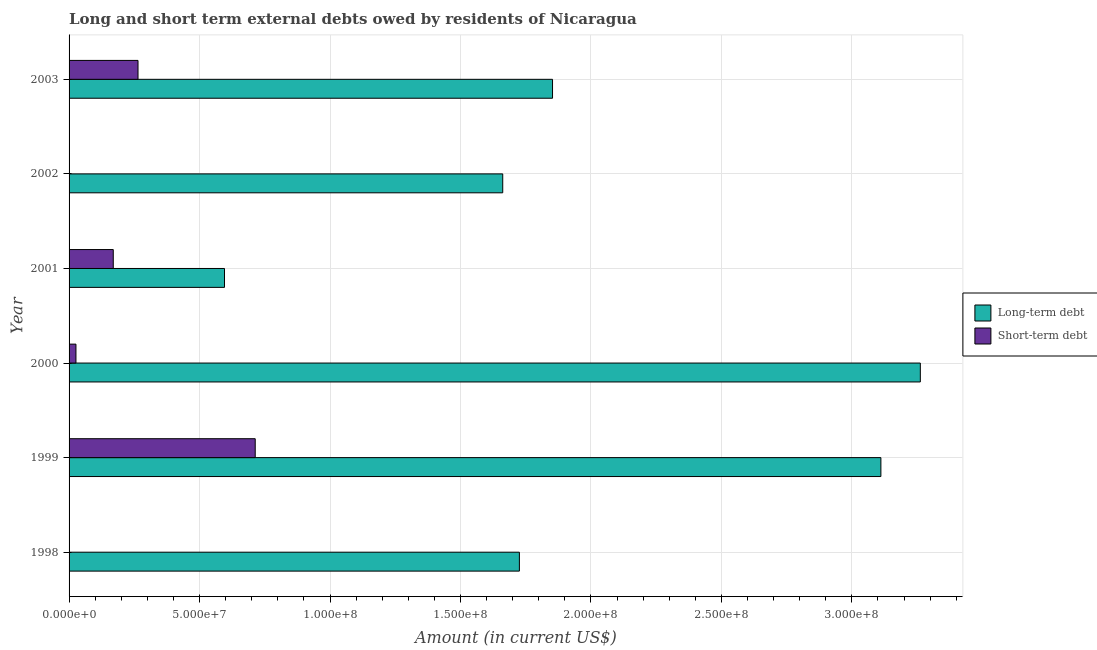Are the number of bars on each tick of the Y-axis equal?
Offer a terse response. No. How many bars are there on the 3rd tick from the bottom?
Offer a terse response. 2. What is the label of the 2nd group of bars from the top?
Keep it short and to the point. 2002. What is the long-term debts owed by residents in 2002?
Provide a succinct answer. 1.66e+08. Across all years, what is the maximum long-term debts owed by residents?
Give a very brief answer. 3.26e+08. Across all years, what is the minimum long-term debts owed by residents?
Your response must be concise. 5.96e+07. What is the total short-term debts owed by residents in the graph?
Offer a very short reply. 1.17e+08. What is the difference between the long-term debts owed by residents in 1999 and that in 2002?
Your answer should be compact. 1.45e+08. What is the difference between the short-term debts owed by residents in 1998 and the long-term debts owed by residents in 2003?
Your answer should be very brief. -1.85e+08. What is the average short-term debts owed by residents per year?
Give a very brief answer. 1.96e+07. In the year 2000, what is the difference between the long-term debts owed by residents and short-term debts owed by residents?
Your response must be concise. 3.24e+08. What is the ratio of the long-term debts owed by residents in 1999 to that in 2000?
Ensure brevity in your answer.  0.95. What is the difference between the highest and the second highest short-term debts owed by residents?
Provide a short and direct response. 4.49e+07. What is the difference between the highest and the lowest short-term debts owed by residents?
Ensure brevity in your answer.  7.13e+07. In how many years, is the short-term debts owed by residents greater than the average short-term debts owed by residents taken over all years?
Your response must be concise. 2. Is the sum of the long-term debts owed by residents in 1998 and 2003 greater than the maximum short-term debts owed by residents across all years?
Offer a terse response. Yes. Are all the bars in the graph horizontal?
Your answer should be very brief. Yes. What is the difference between two consecutive major ticks on the X-axis?
Make the answer very short. 5.00e+07. Does the graph contain grids?
Provide a short and direct response. Yes. What is the title of the graph?
Give a very brief answer. Long and short term external debts owed by residents of Nicaragua. Does "Private funds" appear as one of the legend labels in the graph?
Provide a short and direct response. No. What is the Amount (in current US$) in Long-term debt in 1998?
Provide a short and direct response. 1.73e+08. What is the Amount (in current US$) in Short-term debt in 1998?
Provide a succinct answer. 0. What is the Amount (in current US$) in Long-term debt in 1999?
Provide a short and direct response. 3.11e+08. What is the Amount (in current US$) of Short-term debt in 1999?
Offer a very short reply. 7.13e+07. What is the Amount (in current US$) in Long-term debt in 2000?
Provide a succinct answer. 3.26e+08. What is the Amount (in current US$) of Short-term debt in 2000?
Make the answer very short. 2.64e+06. What is the Amount (in current US$) in Long-term debt in 2001?
Your response must be concise. 5.96e+07. What is the Amount (in current US$) in Short-term debt in 2001?
Offer a very short reply. 1.69e+07. What is the Amount (in current US$) of Long-term debt in 2002?
Keep it short and to the point. 1.66e+08. What is the Amount (in current US$) of Long-term debt in 2003?
Offer a terse response. 1.85e+08. What is the Amount (in current US$) of Short-term debt in 2003?
Give a very brief answer. 2.64e+07. Across all years, what is the maximum Amount (in current US$) of Long-term debt?
Make the answer very short. 3.26e+08. Across all years, what is the maximum Amount (in current US$) in Short-term debt?
Your answer should be compact. 7.13e+07. Across all years, what is the minimum Amount (in current US$) in Long-term debt?
Offer a very short reply. 5.96e+07. What is the total Amount (in current US$) in Long-term debt in the graph?
Offer a terse response. 1.22e+09. What is the total Amount (in current US$) of Short-term debt in the graph?
Ensure brevity in your answer.  1.17e+08. What is the difference between the Amount (in current US$) of Long-term debt in 1998 and that in 1999?
Provide a short and direct response. -1.39e+08. What is the difference between the Amount (in current US$) of Long-term debt in 1998 and that in 2000?
Offer a very short reply. -1.54e+08. What is the difference between the Amount (in current US$) in Long-term debt in 1998 and that in 2001?
Offer a very short reply. 1.13e+08. What is the difference between the Amount (in current US$) in Long-term debt in 1998 and that in 2002?
Your response must be concise. 6.38e+06. What is the difference between the Amount (in current US$) of Long-term debt in 1998 and that in 2003?
Keep it short and to the point. -1.27e+07. What is the difference between the Amount (in current US$) of Long-term debt in 1999 and that in 2000?
Give a very brief answer. -1.51e+07. What is the difference between the Amount (in current US$) of Short-term debt in 1999 and that in 2000?
Provide a short and direct response. 6.87e+07. What is the difference between the Amount (in current US$) in Long-term debt in 1999 and that in 2001?
Ensure brevity in your answer.  2.52e+08. What is the difference between the Amount (in current US$) in Short-term debt in 1999 and that in 2001?
Provide a short and direct response. 5.44e+07. What is the difference between the Amount (in current US$) in Long-term debt in 1999 and that in 2002?
Offer a very short reply. 1.45e+08. What is the difference between the Amount (in current US$) in Long-term debt in 1999 and that in 2003?
Your answer should be very brief. 1.26e+08. What is the difference between the Amount (in current US$) of Short-term debt in 1999 and that in 2003?
Offer a terse response. 4.49e+07. What is the difference between the Amount (in current US$) in Long-term debt in 2000 and that in 2001?
Your response must be concise. 2.67e+08. What is the difference between the Amount (in current US$) of Short-term debt in 2000 and that in 2001?
Provide a succinct answer. -1.43e+07. What is the difference between the Amount (in current US$) in Long-term debt in 2000 and that in 2002?
Your response must be concise. 1.60e+08. What is the difference between the Amount (in current US$) in Long-term debt in 2000 and that in 2003?
Offer a terse response. 1.41e+08. What is the difference between the Amount (in current US$) of Short-term debt in 2000 and that in 2003?
Make the answer very short. -2.38e+07. What is the difference between the Amount (in current US$) in Long-term debt in 2001 and that in 2002?
Your answer should be very brief. -1.07e+08. What is the difference between the Amount (in current US$) of Long-term debt in 2001 and that in 2003?
Your answer should be compact. -1.26e+08. What is the difference between the Amount (in current US$) of Short-term debt in 2001 and that in 2003?
Make the answer very short. -9.48e+06. What is the difference between the Amount (in current US$) in Long-term debt in 2002 and that in 2003?
Offer a terse response. -1.91e+07. What is the difference between the Amount (in current US$) of Long-term debt in 1998 and the Amount (in current US$) of Short-term debt in 1999?
Your response must be concise. 1.01e+08. What is the difference between the Amount (in current US$) in Long-term debt in 1998 and the Amount (in current US$) in Short-term debt in 2000?
Keep it short and to the point. 1.70e+08. What is the difference between the Amount (in current US$) of Long-term debt in 1998 and the Amount (in current US$) of Short-term debt in 2001?
Your response must be concise. 1.56e+08. What is the difference between the Amount (in current US$) of Long-term debt in 1998 and the Amount (in current US$) of Short-term debt in 2003?
Your answer should be very brief. 1.46e+08. What is the difference between the Amount (in current US$) of Long-term debt in 1999 and the Amount (in current US$) of Short-term debt in 2000?
Your answer should be very brief. 3.08e+08. What is the difference between the Amount (in current US$) of Long-term debt in 1999 and the Amount (in current US$) of Short-term debt in 2001?
Ensure brevity in your answer.  2.94e+08. What is the difference between the Amount (in current US$) of Long-term debt in 1999 and the Amount (in current US$) of Short-term debt in 2003?
Provide a succinct answer. 2.85e+08. What is the difference between the Amount (in current US$) of Long-term debt in 2000 and the Amount (in current US$) of Short-term debt in 2001?
Provide a succinct answer. 3.09e+08. What is the difference between the Amount (in current US$) in Long-term debt in 2000 and the Amount (in current US$) in Short-term debt in 2003?
Your answer should be very brief. 3.00e+08. What is the difference between the Amount (in current US$) of Long-term debt in 2001 and the Amount (in current US$) of Short-term debt in 2003?
Offer a very short reply. 3.32e+07. What is the difference between the Amount (in current US$) in Long-term debt in 2002 and the Amount (in current US$) in Short-term debt in 2003?
Your response must be concise. 1.40e+08. What is the average Amount (in current US$) in Long-term debt per year?
Provide a short and direct response. 2.03e+08. What is the average Amount (in current US$) in Short-term debt per year?
Offer a very short reply. 1.96e+07. In the year 1999, what is the difference between the Amount (in current US$) in Long-term debt and Amount (in current US$) in Short-term debt?
Your answer should be very brief. 2.40e+08. In the year 2000, what is the difference between the Amount (in current US$) of Long-term debt and Amount (in current US$) of Short-term debt?
Offer a very short reply. 3.24e+08. In the year 2001, what is the difference between the Amount (in current US$) of Long-term debt and Amount (in current US$) of Short-term debt?
Give a very brief answer. 4.26e+07. In the year 2003, what is the difference between the Amount (in current US$) of Long-term debt and Amount (in current US$) of Short-term debt?
Your answer should be very brief. 1.59e+08. What is the ratio of the Amount (in current US$) in Long-term debt in 1998 to that in 1999?
Offer a terse response. 0.55. What is the ratio of the Amount (in current US$) in Long-term debt in 1998 to that in 2000?
Provide a succinct answer. 0.53. What is the ratio of the Amount (in current US$) in Long-term debt in 1998 to that in 2001?
Offer a terse response. 2.9. What is the ratio of the Amount (in current US$) in Long-term debt in 1998 to that in 2002?
Ensure brevity in your answer.  1.04. What is the ratio of the Amount (in current US$) of Long-term debt in 1998 to that in 2003?
Offer a terse response. 0.93. What is the ratio of the Amount (in current US$) in Long-term debt in 1999 to that in 2000?
Make the answer very short. 0.95. What is the ratio of the Amount (in current US$) in Short-term debt in 1999 to that in 2000?
Provide a succinct answer. 27.02. What is the ratio of the Amount (in current US$) of Long-term debt in 1999 to that in 2001?
Provide a succinct answer. 5.22. What is the ratio of the Amount (in current US$) of Short-term debt in 1999 to that in 2001?
Make the answer very short. 4.21. What is the ratio of the Amount (in current US$) in Long-term debt in 1999 to that in 2002?
Offer a very short reply. 1.87. What is the ratio of the Amount (in current US$) in Long-term debt in 1999 to that in 2003?
Your answer should be compact. 1.68. What is the ratio of the Amount (in current US$) in Short-term debt in 1999 to that in 2003?
Give a very brief answer. 2.7. What is the ratio of the Amount (in current US$) in Long-term debt in 2000 to that in 2001?
Offer a very short reply. 5.48. What is the ratio of the Amount (in current US$) of Short-term debt in 2000 to that in 2001?
Ensure brevity in your answer.  0.16. What is the ratio of the Amount (in current US$) in Long-term debt in 2000 to that in 2002?
Offer a terse response. 1.96. What is the ratio of the Amount (in current US$) in Long-term debt in 2000 to that in 2003?
Offer a very short reply. 1.76. What is the ratio of the Amount (in current US$) of Short-term debt in 2000 to that in 2003?
Give a very brief answer. 0.1. What is the ratio of the Amount (in current US$) in Long-term debt in 2001 to that in 2002?
Your answer should be very brief. 0.36. What is the ratio of the Amount (in current US$) in Long-term debt in 2001 to that in 2003?
Your answer should be very brief. 0.32. What is the ratio of the Amount (in current US$) in Short-term debt in 2001 to that in 2003?
Provide a succinct answer. 0.64. What is the ratio of the Amount (in current US$) of Long-term debt in 2002 to that in 2003?
Offer a terse response. 0.9. What is the difference between the highest and the second highest Amount (in current US$) in Long-term debt?
Your response must be concise. 1.51e+07. What is the difference between the highest and the second highest Amount (in current US$) of Short-term debt?
Your response must be concise. 4.49e+07. What is the difference between the highest and the lowest Amount (in current US$) in Long-term debt?
Offer a very short reply. 2.67e+08. What is the difference between the highest and the lowest Amount (in current US$) in Short-term debt?
Give a very brief answer. 7.13e+07. 